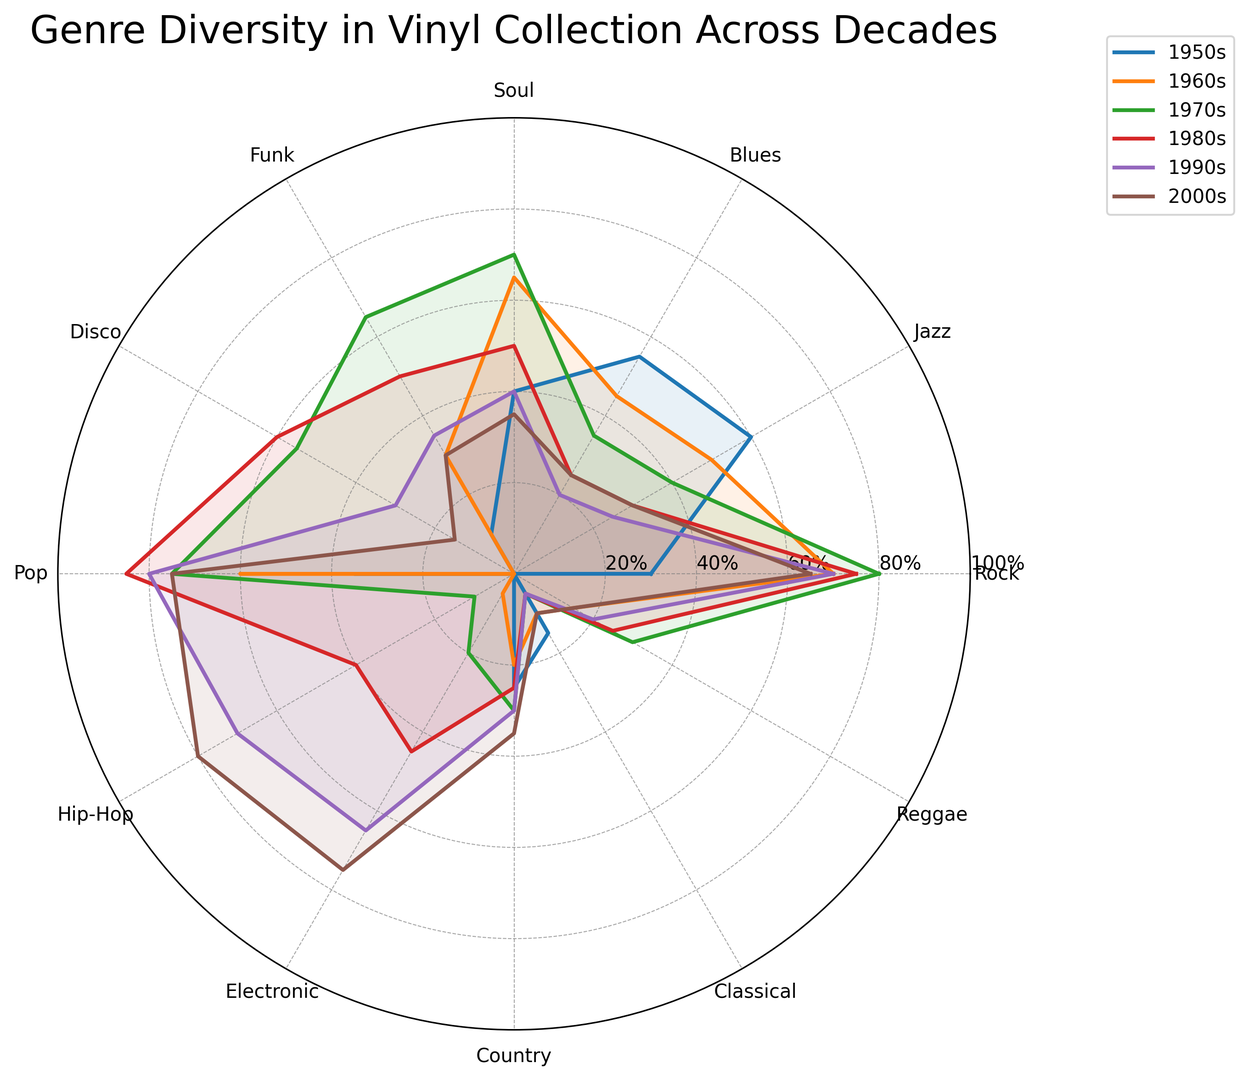What genre had the highest representation in the 1950s? The genre bars in the radar chart show that Jazz had the highest value in the 1950s with 60%.
Answer: Jazz In which decade did Rock peak in representation? The Rock representation line peaks at 80% in the 1970s, higher than any other decade.
Answer: 1970s How does the representation of Hip-Hop in the 2000s compare to the 1990s? The Hip-Hop representation for the 2000s is at 80%, while in the 1990s, it is at 70%. Therefore, it increased by 10% from the 1990s to the 2000s.
Answer: It increased Considering all decades, which genre showed a consistent increase from one decade to the next? Pop shows a consistent upward trend from the 1950s (35%) to the 2000s (75%), increasing steadily in each decade.
Answer: Pop Which decade had the most even distribution of genres? Looking at the radar chart, the 2000s have the most even lengths of lines for different genres, indicating a more balanced distribution across genres.
Answer: 2000s What is the difference in Funk representation between the 1970s and the 1990s? Funk had a representation of 65% in the 1970s and 35% in the 1990s. The difference is 65% - 35% = 30%.
Answer: 30% Which decade had the lowest representation of Classical music? The radar chart shows the smallest value for Classical music in the 1970s and 1980s at 5%.
Answer: 1970s and 1980s How does the representation of Electronic music change over decades? Electronic music starts at 0% in the 1950s, slightly increases to 5% in the 1960s, 20% in the 1970s, and continually grows to 75% by the 2000s.
Answer: It increases What is the average representation of Rock across the decades? The values for Rock are 30%, 70%, 80%, 75%, 70%, and 65%. Sum these to get 390%, then divide by 6 to find the average: 390/6 = 65%.
Answer: 65% Which genres had a representation of 0% in any decade? From the radar chart, Funk and Disco had 0% in the 1950s, and Hip-Hop, Electronic, and Reggae had 0% in the 1950s and 1960s.
Answer: Funk, Disco, Hip-Hop, Electronic, Reggae 